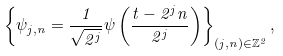<formula> <loc_0><loc_0><loc_500><loc_500>\left \{ \psi _ { j , n } = \frac { 1 } { \sqrt { 2 ^ { j } } } \psi \left ( \frac { t - 2 ^ { j } n } { 2 ^ { j } } \right ) \right \} _ { ( j , n ) \in \mathbb { Z } ^ { 2 } } ,</formula> 